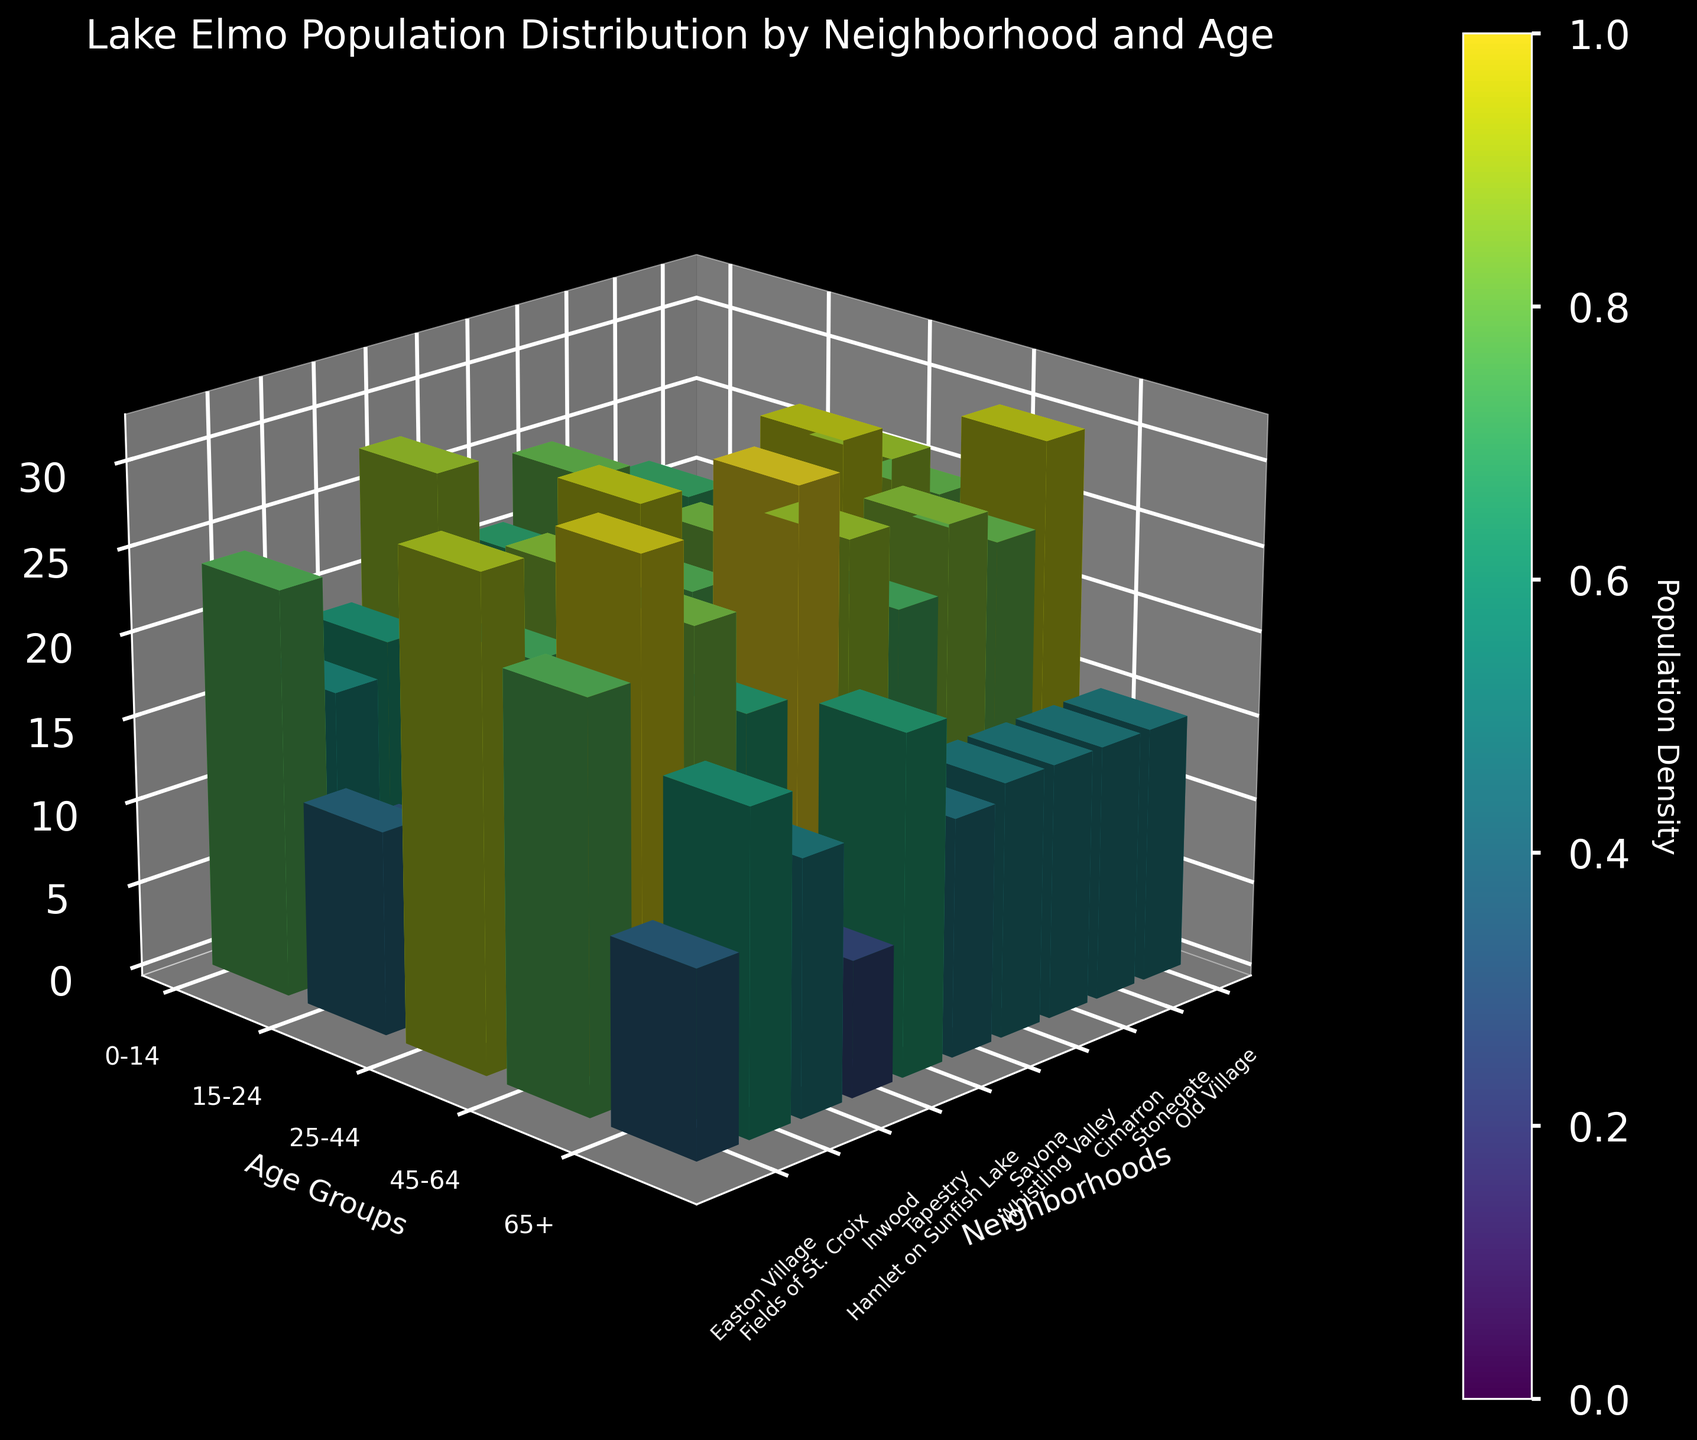what is the title of the figure? The title of the figure is usually displayed at the top of the chart. In this case, you can read it directly as 'Lake Elmo Population Distribution by Neighborhood and Age'.
Answer: Lake Elmo Population Distribution by Neighborhood and Age Which neighborhood has the highest population density? By looking for the tallest bars in the 3D bar chart, 'Tapestry' neighborhood appears to have the highest population density compared to other neighborhoods.
Answer: Tapestry How many age groups are compared in the figure? The y-axis displays different age groups. By counting, you find there are five age groups: '0-14', '15-24', '25-44', '45-64', and '65+'.
Answer: 5 In which neighborhood does the age group '25-44' have the highest population? Find the bars labeled '25-44' for each neighborhood and compare their heights. 'Cimarron' has the tallest bar for this age group.
Answer: Cimarron What's the sum of the population for the '45-64' age group across all neighborhoods? Sum the values of '45-64' across all neighborhoods: 30 (Old Village) + 25 (Stonegate) + 27 (Cimarron) + 23 (Whistling Valley) + 28 (Savona) + 32 (Hamlet on Sunfish Lake) + 20 (Tapestry) + 26 (Inwood) + 31 (Fields of St. Croix) + 24 (Easton Village) = 266.
Answer: 266 Compare the population of age group '0-14' in 'Tapestry' and 'Easton Village'. Which is higher? Check the height of the bars for the '0-14' age group in both neighborhoods. Tapestry's bar is taller than Easton Village's.
Answer: Tapestry Which age group has 12 people in 'Easton Village'? Refer to the bar of height 12 in 'Easton Village'. The age group associated with it is '15-24'.
Answer: 15-24 Which neighborhood has the lowest total population across all age groups? Add the populations of all age groups for each neighborhood. 'Hamlet on Sunfish Lake' has the lowest total, summing up to 100.
Answer: Hamlet on Sunfish Lake What is the difference in population between the '65+' and '0-14' age groups in 'Hamlet on Sunfish Lake'? Subtract the 0-14 population from the 65+ population in 'Hamlet on Sunfish Lake': 20 (65+) - 15 (0-14) = 5.
Answer: 5 Are there more people in the '65+' age group in 'Fields of St. Croix' or 'Old Village'? Compare the height of bars for '65+' in both neighborhoods. 'Fields of St. Croix' has a higher population in this age group with 19 compared to 15 in 'Old Village'.
Answer: Fields of St. Croix 